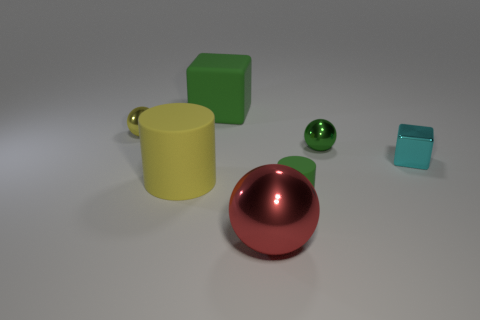Subtract 1 balls. How many balls are left? 2 Add 2 red spheres. How many objects exist? 9 Subtract all spheres. How many objects are left? 4 Add 2 yellow objects. How many yellow objects exist? 4 Subtract 1 cyan blocks. How many objects are left? 6 Subtract all rubber cylinders. Subtract all large red metal spheres. How many objects are left? 4 Add 6 tiny green rubber cylinders. How many tiny green rubber cylinders are left? 7 